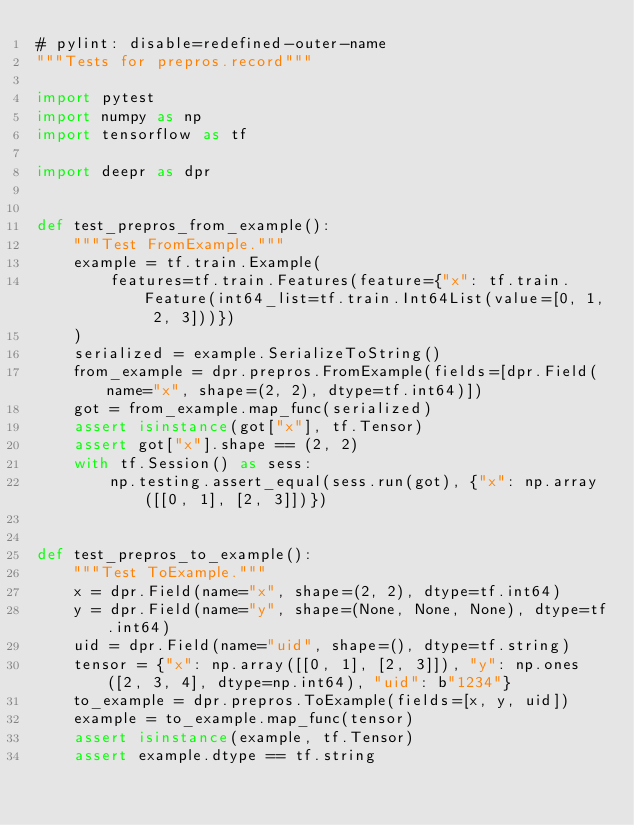<code> <loc_0><loc_0><loc_500><loc_500><_Python_># pylint: disable=redefined-outer-name
"""Tests for prepros.record"""

import pytest
import numpy as np
import tensorflow as tf

import deepr as dpr


def test_prepros_from_example():
    """Test FromExample."""
    example = tf.train.Example(
        features=tf.train.Features(feature={"x": tf.train.Feature(int64_list=tf.train.Int64List(value=[0, 1, 2, 3]))})
    )
    serialized = example.SerializeToString()
    from_example = dpr.prepros.FromExample(fields=[dpr.Field(name="x", shape=(2, 2), dtype=tf.int64)])
    got = from_example.map_func(serialized)
    assert isinstance(got["x"], tf.Tensor)
    assert got["x"].shape == (2, 2)
    with tf.Session() as sess:
        np.testing.assert_equal(sess.run(got), {"x": np.array([[0, 1], [2, 3]])})


def test_prepros_to_example():
    """Test ToExample."""
    x = dpr.Field(name="x", shape=(2, 2), dtype=tf.int64)
    y = dpr.Field(name="y", shape=(None, None, None), dtype=tf.int64)
    uid = dpr.Field(name="uid", shape=(), dtype=tf.string)
    tensor = {"x": np.array([[0, 1], [2, 3]]), "y": np.ones([2, 3, 4], dtype=np.int64), "uid": b"1234"}
    to_example = dpr.prepros.ToExample(fields=[x, y, uid])
    example = to_example.map_func(tensor)
    assert isinstance(example, tf.Tensor)
    assert example.dtype == tf.string</code> 